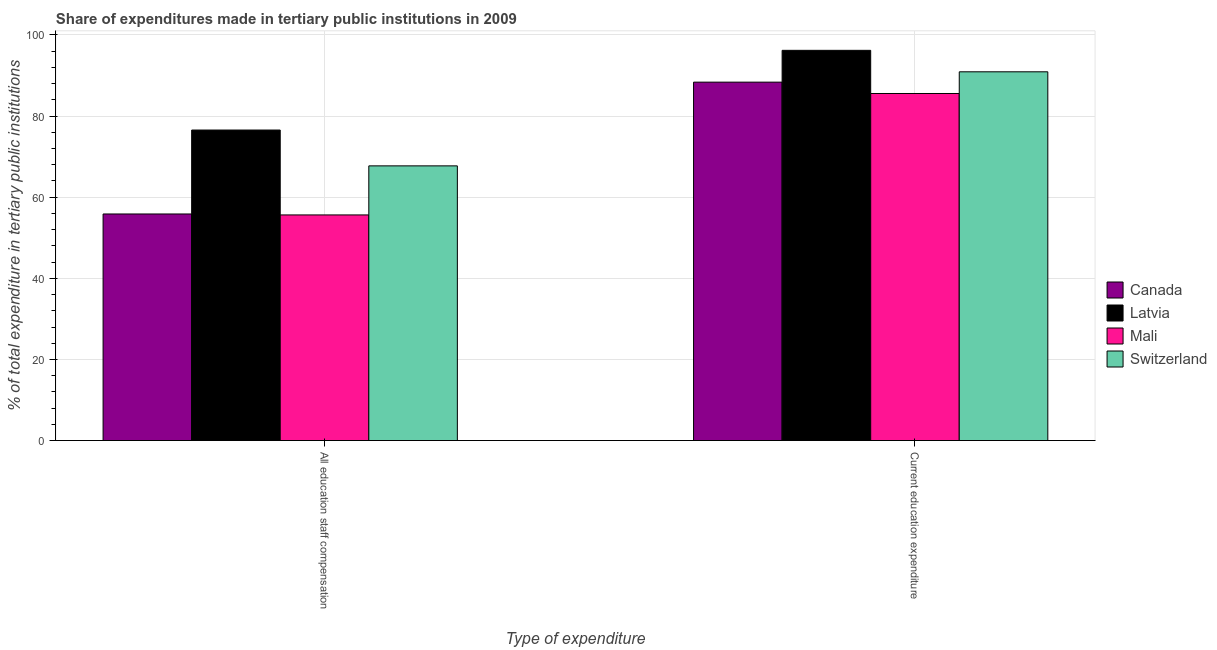How many different coloured bars are there?
Give a very brief answer. 4. How many groups of bars are there?
Your response must be concise. 2. What is the label of the 2nd group of bars from the left?
Offer a terse response. Current education expenditure. What is the expenditure in education in Canada?
Your answer should be compact. 88.37. Across all countries, what is the maximum expenditure in education?
Provide a short and direct response. 96.21. Across all countries, what is the minimum expenditure in staff compensation?
Provide a short and direct response. 55.63. In which country was the expenditure in staff compensation maximum?
Provide a succinct answer. Latvia. In which country was the expenditure in staff compensation minimum?
Your response must be concise. Mali. What is the total expenditure in education in the graph?
Provide a short and direct response. 361.05. What is the difference between the expenditure in staff compensation in Latvia and that in Mali?
Provide a succinct answer. 20.93. What is the difference between the expenditure in staff compensation in Switzerland and the expenditure in education in Canada?
Ensure brevity in your answer.  -20.64. What is the average expenditure in staff compensation per country?
Make the answer very short. 63.94. What is the difference between the expenditure in education and expenditure in staff compensation in Switzerland?
Keep it short and to the point. 23.19. In how many countries, is the expenditure in staff compensation greater than 84 %?
Your response must be concise. 0. What is the ratio of the expenditure in education in Canada to that in Switzerland?
Ensure brevity in your answer.  0.97. What does the 4th bar from the left in All education staff compensation represents?
Make the answer very short. Switzerland. What does the 1st bar from the right in Current education expenditure represents?
Provide a short and direct response. Switzerland. Are all the bars in the graph horizontal?
Offer a very short reply. No. How many countries are there in the graph?
Keep it short and to the point. 4. Are the values on the major ticks of Y-axis written in scientific E-notation?
Provide a succinct answer. No. What is the title of the graph?
Your response must be concise. Share of expenditures made in tertiary public institutions in 2009. What is the label or title of the X-axis?
Provide a succinct answer. Type of expenditure. What is the label or title of the Y-axis?
Make the answer very short. % of total expenditure in tertiary public institutions. What is the % of total expenditure in tertiary public institutions of Canada in All education staff compensation?
Make the answer very short. 55.87. What is the % of total expenditure in tertiary public institutions of Latvia in All education staff compensation?
Offer a very short reply. 76.56. What is the % of total expenditure in tertiary public institutions in Mali in All education staff compensation?
Make the answer very short. 55.63. What is the % of total expenditure in tertiary public institutions in Switzerland in All education staff compensation?
Offer a terse response. 67.73. What is the % of total expenditure in tertiary public institutions in Canada in Current education expenditure?
Your answer should be very brief. 88.37. What is the % of total expenditure in tertiary public institutions in Latvia in Current education expenditure?
Give a very brief answer. 96.21. What is the % of total expenditure in tertiary public institutions of Mali in Current education expenditure?
Your answer should be very brief. 85.57. What is the % of total expenditure in tertiary public institutions of Switzerland in Current education expenditure?
Offer a terse response. 90.91. Across all Type of expenditure, what is the maximum % of total expenditure in tertiary public institutions of Canada?
Ensure brevity in your answer.  88.37. Across all Type of expenditure, what is the maximum % of total expenditure in tertiary public institutions in Latvia?
Your answer should be very brief. 96.21. Across all Type of expenditure, what is the maximum % of total expenditure in tertiary public institutions in Mali?
Provide a short and direct response. 85.57. Across all Type of expenditure, what is the maximum % of total expenditure in tertiary public institutions of Switzerland?
Offer a terse response. 90.91. Across all Type of expenditure, what is the minimum % of total expenditure in tertiary public institutions in Canada?
Your answer should be compact. 55.87. Across all Type of expenditure, what is the minimum % of total expenditure in tertiary public institutions in Latvia?
Provide a succinct answer. 76.56. Across all Type of expenditure, what is the minimum % of total expenditure in tertiary public institutions of Mali?
Ensure brevity in your answer.  55.63. Across all Type of expenditure, what is the minimum % of total expenditure in tertiary public institutions of Switzerland?
Provide a succinct answer. 67.73. What is the total % of total expenditure in tertiary public institutions of Canada in the graph?
Make the answer very short. 144.23. What is the total % of total expenditure in tertiary public institutions of Latvia in the graph?
Provide a succinct answer. 172.76. What is the total % of total expenditure in tertiary public institutions of Mali in the graph?
Ensure brevity in your answer.  141.2. What is the total % of total expenditure in tertiary public institutions of Switzerland in the graph?
Your answer should be very brief. 158.64. What is the difference between the % of total expenditure in tertiary public institutions of Canada in All education staff compensation and that in Current education expenditure?
Keep it short and to the point. -32.5. What is the difference between the % of total expenditure in tertiary public institutions in Latvia in All education staff compensation and that in Current education expenditure?
Keep it short and to the point. -19.65. What is the difference between the % of total expenditure in tertiary public institutions of Mali in All education staff compensation and that in Current education expenditure?
Your answer should be very brief. -29.94. What is the difference between the % of total expenditure in tertiary public institutions in Switzerland in All education staff compensation and that in Current education expenditure?
Offer a very short reply. -23.19. What is the difference between the % of total expenditure in tertiary public institutions of Canada in All education staff compensation and the % of total expenditure in tertiary public institutions of Latvia in Current education expenditure?
Keep it short and to the point. -40.34. What is the difference between the % of total expenditure in tertiary public institutions of Canada in All education staff compensation and the % of total expenditure in tertiary public institutions of Mali in Current education expenditure?
Your response must be concise. -29.7. What is the difference between the % of total expenditure in tertiary public institutions of Canada in All education staff compensation and the % of total expenditure in tertiary public institutions of Switzerland in Current education expenditure?
Offer a terse response. -35.05. What is the difference between the % of total expenditure in tertiary public institutions in Latvia in All education staff compensation and the % of total expenditure in tertiary public institutions in Mali in Current education expenditure?
Make the answer very short. -9.01. What is the difference between the % of total expenditure in tertiary public institutions in Latvia in All education staff compensation and the % of total expenditure in tertiary public institutions in Switzerland in Current education expenditure?
Provide a succinct answer. -14.36. What is the difference between the % of total expenditure in tertiary public institutions in Mali in All education staff compensation and the % of total expenditure in tertiary public institutions in Switzerland in Current education expenditure?
Keep it short and to the point. -35.28. What is the average % of total expenditure in tertiary public institutions in Canada per Type of expenditure?
Give a very brief answer. 72.12. What is the average % of total expenditure in tertiary public institutions in Latvia per Type of expenditure?
Keep it short and to the point. 86.38. What is the average % of total expenditure in tertiary public institutions of Mali per Type of expenditure?
Offer a terse response. 70.6. What is the average % of total expenditure in tertiary public institutions of Switzerland per Type of expenditure?
Your answer should be very brief. 79.32. What is the difference between the % of total expenditure in tertiary public institutions in Canada and % of total expenditure in tertiary public institutions in Latvia in All education staff compensation?
Offer a very short reply. -20.69. What is the difference between the % of total expenditure in tertiary public institutions of Canada and % of total expenditure in tertiary public institutions of Mali in All education staff compensation?
Your answer should be very brief. 0.24. What is the difference between the % of total expenditure in tertiary public institutions in Canada and % of total expenditure in tertiary public institutions in Switzerland in All education staff compensation?
Offer a terse response. -11.86. What is the difference between the % of total expenditure in tertiary public institutions of Latvia and % of total expenditure in tertiary public institutions of Mali in All education staff compensation?
Offer a terse response. 20.93. What is the difference between the % of total expenditure in tertiary public institutions of Latvia and % of total expenditure in tertiary public institutions of Switzerland in All education staff compensation?
Your response must be concise. 8.83. What is the difference between the % of total expenditure in tertiary public institutions in Mali and % of total expenditure in tertiary public institutions in Switzerland in All education staff compensation?
Ensure brevity in your answer.  -12.1. What is the difference between the % of total expenditure in tertiary public institutions in Canada and % of total expenditure in tertiary public institutions in Latvia in Current education expenditure?
Your response must be concise. -7.84. What is the difference between the % of total expenditure in tertiary public institutions in Canada and % of total expenditure in tertiary public institutions in Mali in Current education expenditure?
Your answer should be very brief. 2.8. What is the difference between the % of total expenditure in tertiary public institutions in Canada and % of total expenditure in tertiary public institutions in Switzerland in Current education expenditure?
Make the answer very short. -2.55. What is the difference between the % of total expenditure in tertiary public institutions in Latvia and % of total expenditure in tertiary public institutions in Mali in Current education expenditure?
Offer a terse response. 10.64. What is the difference between the % of total expenditure in tertiary public institutions in Latvia and % of total expenditure in tertiary public institutions in Switzerland in Current education expenditure?
Make the answer very short. 5.29. What is the difference between the % of total expenditure in tertiary public institutions of Mali and % of total expenditure in tertiary public institutions of Switzerland in Current education expenditure?
Keep it short and to the point. -5.34. What is the ratio of the % of total expenditure in tertiary public institutions of Canada in All education staff compensation to that in Current education expenditure?
Give a very brief answer. 0.63. What is the ratio of the % of total expenditure in tertiary public institutions in Latvia in All education staff compensation to that in Current education expenditure?
Ensure brevity in your answer.  0.8. What is the ratio of the % of total expenditure in tertiary public institutions of Mali in All education staff compensation to that in Current education expenditure?
Give a very brief answer. 0.65. What is the ratio of the % of total expenditure in tertiary public institutions of Switzerland in All education staff compensation to that in Current education expenditure?
Give a very brief answer. 0.74. What is the difference between the highest and the second highest % of total expenditure in tertiary public institutions in Canada?
Offer a terse response. 32.5. What is the difference between the highest and the second highest % of total expenditure in tertiary public institutions of Latvia?
Keep it short and to the point. 19.65. What is the difference between the highest and the second highest % of total expenditure in tertiary public institutions in Mali?
Your response must be concise. 29.94. What is the difference between the highest and the second highest % of total expenditure in tertiary public institutions of Switzerland?
Your answer should be compact. 23.19. What is the difference between the highest and the lowest % of total expenditure in tertiary public institutions of Canada?
Offer a terse response. 32.5. What is the difference between the highest and the lowest % of total expenditure in tertiary public institutions in Latvia?
Your response must be concise. 19.65. What is the difference between the highest and the lowest % of total expenditure in tertiary public institutions in Mali?
Offer a terse response. 29.94. What is the difference between the highest and the lowest % of total expenditure in tertiary public institutions in Switzerland?
Ensure brevity in your answer.  23.19. 